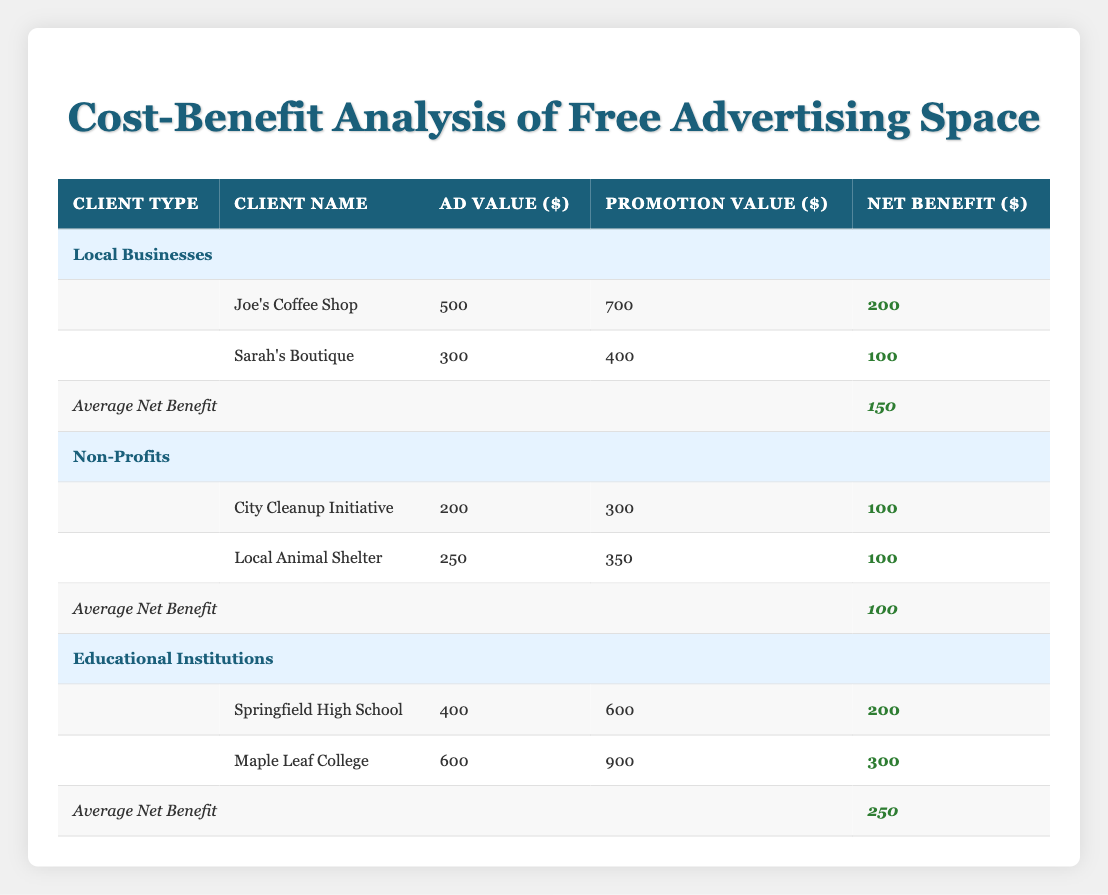What is the Net Benefit for Joe's Coffee Shop? The table shows that the Net Benefit for Joe's Coffee Shop is $200.
Answer: 200 What is the average Net Benefit for Educational Institutions? According to the table, the average Net Benefit for Educational Institutions is calculated as $250.
Answer: 250 Is Sarah's Boutique's Promotion Value greater than its Ad Value? Looking at the table, Sarah's Boutique has a Promotion Value of $400 and an Ad Value of $300, which confirms that the Promotion Value is indeed greater.
Answer: Yes Which client type has the highest Average Net Benefit? The table indicates the Average Net Benefit for Local Businesses is $150, for Non-Profits it is $100, and for Educational Institutions, it is $250. Thus, Educational Institutions have the highest average.
Answer: Educational Institutions What is the total Ad Value for all clients in Local Businesses? To find the total Ad Value, we add Joe's Coffee Shop's Ad Value of $500 to Sarah's Boutique's Ad Value of $300, which results in $800.
Answer: 800 What is the difference in Net Benefit between Maple Leaf College and City Cleanup Initiative? Maple Leaf College has a Net Benefit of $300, and City Cleanup Initiative has a Net Benefit of $100. The difference is $300 - $100 = $200.
Answer: 200 Are there any clients in the Non-Profits category with the same Net Benefit? The table shows that both City Cleanup Initiative and Local Animal Shelter have a Net Benefit of $100, which confirms that there are clients in this category with the same value.
Answer: Yes Which client has the highest Ad Value among all listed? According to the table, Maple Leaf College has the highest Ad Value of $600, which is more than any other client listed.
Answer: Maple Leaf College What is the total Promotion Value for all clients in Non-Profits? The Promotion Value for City Cleanup Initiative is $300, and for Local Animal Shelter, it is $350. Adding these together gives us a total of $300 + $350 = $650.
Answer: 650 